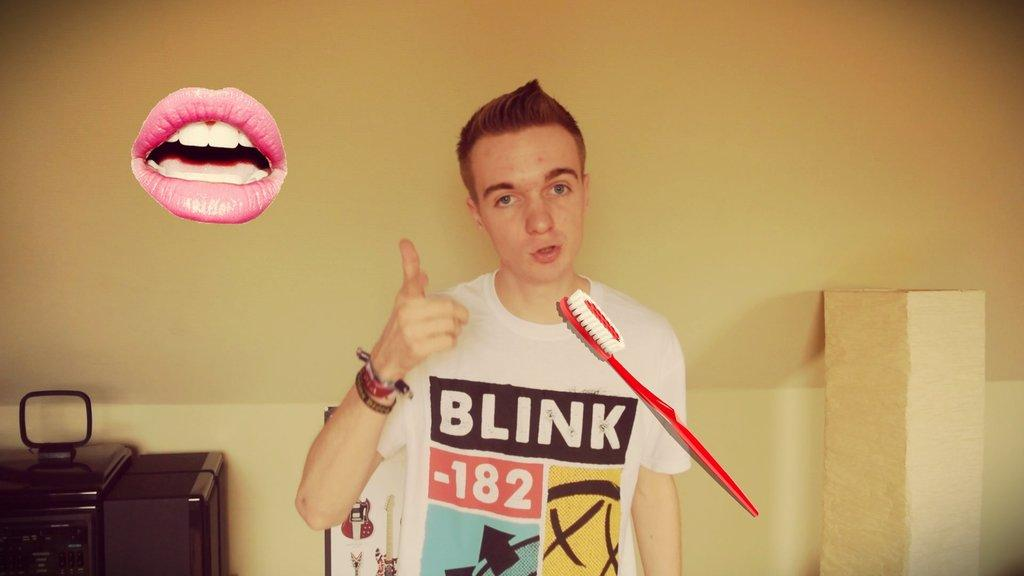<image>
Describe the image concisely. A teenage boy sports a Blink 182 t-shirt and a casual expression. 